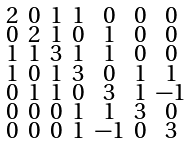<formula> <loc_0><loc_0><loc_500><loc_500>\begin{smallmatrix} 2 & 0 & 1 & 1 & 0 & 0 & 0 \\ 0 & 2 & 1 & 0 & 1 & 0 & 0 \\ 1 & 1 & 3 & 1 & 1 & 0 & 0 \\ 1 & 0 & 1 & 3 & 0 & 1 & 1 \\ 0 & 1 & 1 & 0 & 3 & 1 & - 1 \\ 0 & 0 & 0 & 1 & 1 & 3 & 0 \\ 0 & 0 & 0 & 1 & - 1 & 0 & 3 \end{smallmatrix}</formula> 